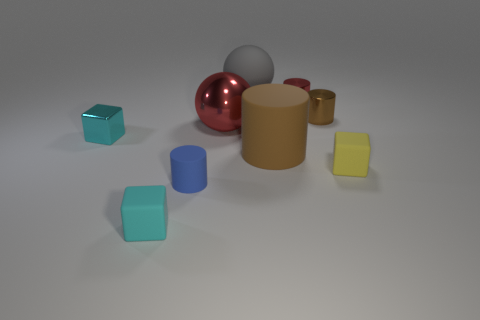There is a small metallic object in front of the red ball; does it have the same color as the rubber block on the left side of the metal ball?
Make the answer very short. Yes. There is another big thing that is the same shape as the big metal object; what material is it?
Your answer should be very brief. Rubber. Are there any spheres made of the same material as the yellow thing?
Offer a terse response. Yes. Is the large red object made of the same material as the tiny brown cylinder?
Keep it short and to the point. Yes. What number of purple things are either metal cylinders or big matte cylinders?
Provide a succinct answer. 0. Are there more large cylinders in front of the small cyan matte thing than yellow metallic blocks?
Provide a short and direct response. No. Is there a tiny shiny cylinder that has the same color as the large cylinder?
Provide a short and direct response. Yes. The cyan rubber object is what size?
Your response must be concise. Small. What number of objects are small red things or tiny rubber cubes in front of the small yellow matte block?
Ensure brevity in your answer.  2. How many small metal blocks are right of the rubber block that is in front of the tiny block that is right of the large cylinder?
Your response must be concise. 0. 